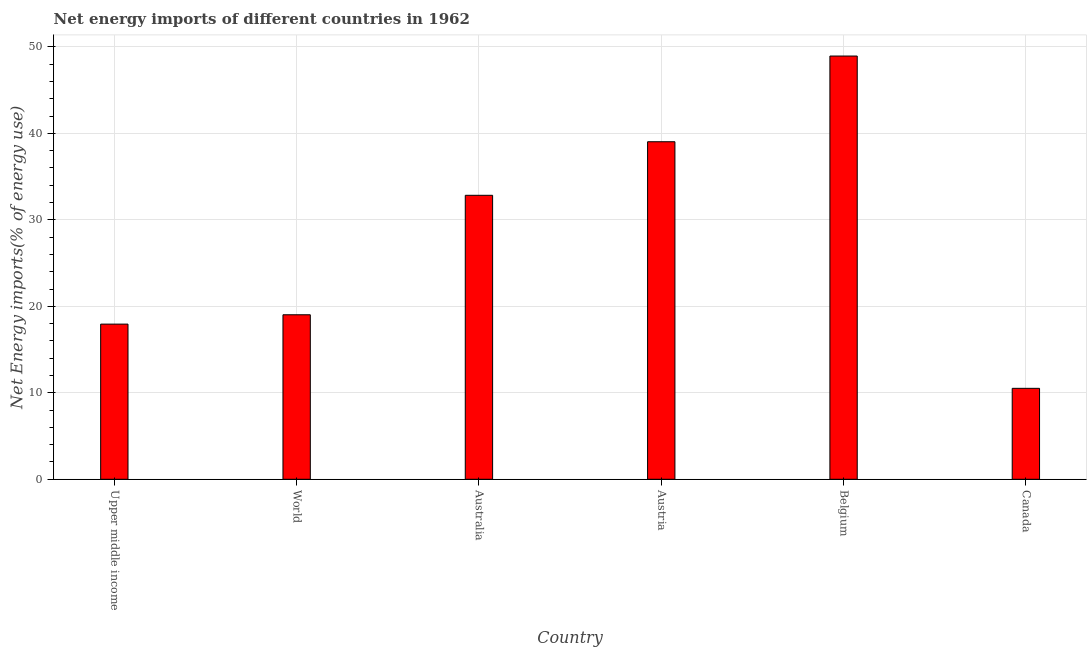What is the title of the graph?
Offer a terse response. Net energy imports of different countries in 1962. What is the label or title of the X-axis?
Ensure brevity in your answer.  Country. What is the label or title of the Y-axis?
Ensure brevity in your answer.  Net Energy imports(% of energy use). What is the energy imports in World?
Offer a very short reply. 19.02. Across all countries, what is the maximum energy imports?
Make the answer very short. 48.94. Across all countries, what is the minimum energy imports?
Offer a very short reply. 10.52. In which country was the energy imports maximum?
Provide a succinct answer. Belgium. In which country was the energy imports minimum?
Provide a succinct answer. Canada. What is the sum of the energy imports?
Offer a terse response. 168.29. What is the difference between the energy imports in Australia and Canada?
Offer a terse response. 22.32. What is the average energy imports per country?
Ensure brevity in your answer.  28.05. What is the median energy imports?
Your answer should be compact. 25.93. What is the ratio of the energy imports in Austria to that in Canada?
Keep it short and to the point. 3.71. Is the energy imports in Australia less than that in Canada?
Provide a succinct answer. No. Is the difference between the energy imports in Australia and Upper middle income greater than the difference between any two countries?
Your answer should be compact. No. What is the difference between the highest and the second highest energy imports?
Make the answer very short. 9.91. Is the sum of the energy imports in Australia and Austria greater than the maximum energy imports across all countries?
Your answer should be very brief. Yes. What is the difference between the highest and the lowest energy imports?
Your response must be concise. 38.43. In how many countries, is the energy imports greater than the average energy imports taken over all countries?
Your answer should be very brief. 3. How many bars are there?
Your response must be concise. 6. Are all the bars in the graph horizontal?
Your answer should be very brief. No. What is the Net Energy imports(% of energy use) of Upper middle income?
Make the answer very short. 17.94. What is the Net Energy imports(% of energy use) in World?
Your answer should be very brief. 19.02. What is the Net Energy imports(% of energy use) in Australia?
Your response must be concise. 32.84. What is the Net Energy imports(% of energy use) of Austria?
Give a very brief answer. 39.03. What is the Net Energy imports(% of energy use) of Belgium?
Give a very brief answer. 48.94. What is the Net Energy imports(% of energy use) in Canada?
Your answer should be compact. 10.52. What is the difference between the Net Energy imports(% of energy use) in Upper middle income and World?
Your answer should be very brief. -1.08. What is the difference between the Net Energy imports(% of energy use) in Upper middle income and Australia?
Your answer should be compact. -14.89. What is the difference between the Net Energy imports(% of energy use) in Upper middle income and Austria?
Your answer should be very brief. -21.09. What is the difference between the Net Energy imports(% of energy use) in Upper middle income and Belgium?
Your answer should be very brief. -31. What is the difference between the Net Energy imports(% of energy use) in Upper middle income and Canada?
Provide a succinct answer. 7.43. What is the difference between the Net Energy imports(% of energy use) in World and Australia?
Offer a very short reply. -13.81. What is the difference between the Net Energy imports(% of energy use) in World and Austria?
Your answer should be compact. -20.01. What is the difference between the Net Energy imports(% of energy use) in World and Belgium?
Give a very brief answer. -29.92. What is the difference between the Net Energy imports(% of energy use) in World and Canada?
Make the answer very short. 8.51. What is the difference between the Net Energy imports(% of energy use) in Australia and Austria?
Keep it short and to the point. -6.19. What is the difference between the Net Energy imports(% of energy use) in Australia and Belgium?
Provide a succinct answer. -16.1. What is the difference between the Net Energy imports(% of energy use) in Australia and Canada?
Ensure brevity in your answer.  22.32. What is the difference between the Net Energy imports(% of energy use) in Austria and Belgium?
Offer a terse response. -9.91. What is the difference between the Net Energy imports(% of energy use) in Austria and Canada?
Offer a terse response. 28.52. What is the difference between the Net Energy imports(% of energy use) in Belgium and Canada?
Your response must be concise. 38.43. What is the ratio of the Net Energy imports(% of energy use) in Upper middle income to that in World?
Ensure brevity in your answer.  0.94. What is the ratio of the Net Energy imports(% of energy use) in Upper middle income to that in Australia?
Ensure brevity in your answer.  0.55. What is the ratio of the Net Energy imports(% of energy use) in Upper middle income to that in Austria?
Provide a succinct answer. 0.46. What is the ratio of the Net Energy imports(% of energy use) in Upper middle income to that in Belgium?
Make the answer very short. 0.37. What is the ratio of the Net Energy imports(% of energy use) in Upper middle income to that in Canada?
Provide a short and direct response. 1.71. What is the ratio of the Net Energy imports(% of energy use) in World to that in Australia?
Ensure brevity in your answer.  0.58. What is the ratio of the Net Energy imports(% of energy use) in World to that in Austria?
Give a very brief answer. 0.49. What is the ratio of the Net Energy imports(% of energy use) in World to that in Belgium?
Provide a short and direct response. 0.39. What is the ratio of the Net Energy imports(% of energy use) in World to that in Canada?
Your response must be concise. 1.81. What is the ratio of the Net Energy imports(% of energy use) in Australia to that in Austria?
Your answer should be compact. 0.84. What is the ratio of the Net Energy imports(% of energy use) in Australia to that in Belgium?
Your answer should be compact. 0.67. What is the ratio of the Net Energy imports(% of energy use) in Australia to that in Canada?
Make the answer very short. 3.12. What is the ratio of the Net Energy imports(% of energy use) in Austria to that in Belgium?
Provide a short and direct response. 0.8. What is the ratio of the Net Energy imports(% of energy use) in Austria to that in Canada?
Provide a succinct answer. 3.71. What is the ratio of the Net Energy imports(% of energy use) in Belgium to that in Canada?
Provide a succinct answer. 4.65. 